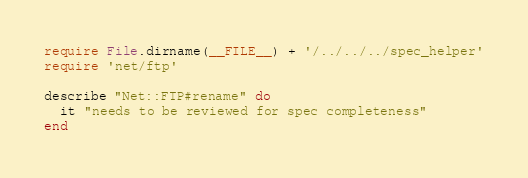Convert code to text. <code><loc_0><loc_0><loc_500><loc_500><_Ruby_>require File.dirname(__FILE__) + '/../../../spec_helper'
require 'net/ftp'

describe "Net::FTP#rename" do
  it "needs to be reviewed for spec completeness"
end
</code> 